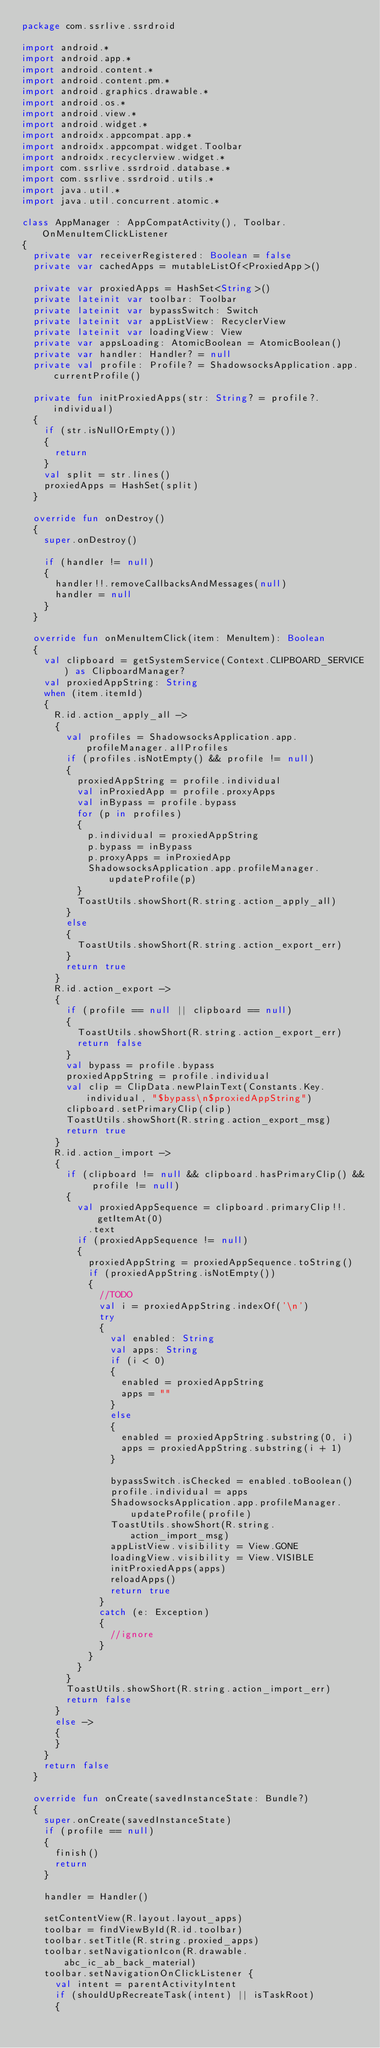Convert code to text. <code><loc_0><loc_0><loc_500><loc_500><_Kotlin_>package com.ssrlive.ssrdroid

import android.*
import android.app.*
import android.content.*
import android.content.pm.*
import android.graphics.drawable.*
import android.os.*
import android.view.*
import android.widget.*
import androidx.appcompat.app.*
import androidx.appcompat.widget.Toolbar
import androidx.recyclerview.widget.*
import com.ssrlive.ssrdroid.database.*
import com.ssrlive.ssrdroid.utils.*
import java.util.*
import java.util.concurrent.atomic.*

class AppManager : AppCompatActivity(), Toolbar.OnMenuItemClickListener
{
	private var receiverRegistered: Boolean = false
	private var cachedApps = mutableListOf<ProxiedApp>()

	private var proxiedApps = HashSet<String>()
	private lateinit var toolbar: Toolbar
	private lateinit var bypassSwitch: Switch
	private lateinit var appListView: RecyclerView
	private lateinit var loadingView: View
	private var appsLoading: AtomicBoolean = AtomicBoolean()
	private var handler: Handler? = null
	private val profile: Profile? = ShadowsocksApplication.app.currentProfile()

	private fun initProxiedApps(str: String? = profile?.individual)
	{
		if (str.isNullOrEmpty())
		{
			return
		}
		val split = str.lines()
		proxiedApps = HashSet(split)
	}

	override fun onDestroy()
	{
		super.onDestroy()

		if (handler != null)
		{
			handler!!.removeCallbacksAndMessages(null)
			handler = null
		}
	}

	override fun onMenuItemClick(item: MenuItem): Boolean
	{
		val clipboard = getSystemService(Context.CLIPBOARD_SERVICE) as ClipboardManager?
		val proxiedAppString: String
		when (item.itemId)
		{
			R.id.action_apply_all ->
			{
				val profiles = ShadowsocksApplication.app.profileManager.allProfiles
				if (profiles.isNotEmpty() && profile != null)
				{
					proxiedAppString = profile.individual
					val inProxiedApp = profile.proxyApps
					val inBypass = profile.bypass
					for (p in profiles)
					{
						p.individual = proxiedAppString
						p.bypass = inBypass
						p.proxyApps = inProxiedApp
						ShadowsocksApplication.app.profileManager.updateProfile(p)
					}
					ToastUtils.showShort(R.string.action_apply_all)
				}
				else
				{
					ToastUtils.showShort(R.string.action_export_err)
				}
				return true
			}
			R.id.action_export ->
			{
				if (profile == null || clipboard == null)
				{
					ToastUtils.showShort(R.string.action_export_err)
					return false
				}
				val bypass = profile.bypass
				proxiedAppString = profile.individual
				val clip = ClipData.newPlainText(Constants.Key.individual, "$bypass\n$proxiedAppString")
				clipboard.setPrimaryClip(clip)
				ToastUtils.showShort(R.string.action_export_msg)
				return true
			}
			R.id.action_import ->
			{
				if (clipboard != null && clipboard.hasPrimaryClip() && profile != null)
				{
					val proxiedAppSequence = clipboard.primaryClip!!.getItemAt(0)
						.text
					if (proxiedAppSequence != null)
					{
						proxiedAppString = proxiedAppSequence.toString()
						if (proxiedAppString.isNotEmpty())
						{
							//TODO
							val i = proxiedAppString.indexOf('\n')
							try
							{
								val enabled: String
								val apps: String
								if (i < 0)
								{
									enabled = proxiedAppString
									apps = ""
								}
								else
								{
									enabled = proxiedAppString.substring(0, i)
									apps = proxiedAppString.substring(i + 1)
								}

								bypassSwitch.isChecked = enabled.toBoolean()
								profile.individual = apps
								ShadowsocksApplication.app.profileManager.updateProfile(profile)
								ToastUtils.showShort(R.string.action_import_msg)
								appListView.visibility = View.GONE
								loadingView.visibility = View.VISIBLE
								initProxiedApps(apps)
								reloadApps()
								return true
							}
							catch (e: Exception)
							{
								//ignore
							}
						}
					}
				}
				ToastUtils.showShort(R.string.action_import_err)
				return false
			}
			else ->
			{
			}
		}
		return false
	}

	override fun onCreate(savedInstanceState: Bundle?)
	{
		super.onCreate(savedInstanceState)
		if (profile == null)
		{
			finish()
			return
		}

		handler = Handler()

		setContentView(R.layout.layout_apps)
		toolbar = findViewById(R.id.toolbar)
		toolbar.setTitle(R.string.proxied_apps)
		toolbar.setNavigationIcon(R.drawable.abc_ic_ab_back_material)
		toolbar.setNavigationOnClickListener {
			val intent = parentActivityIntent
			if (shouldUpRecreateTask(intent) || isTaskRoot)
			{</code> 